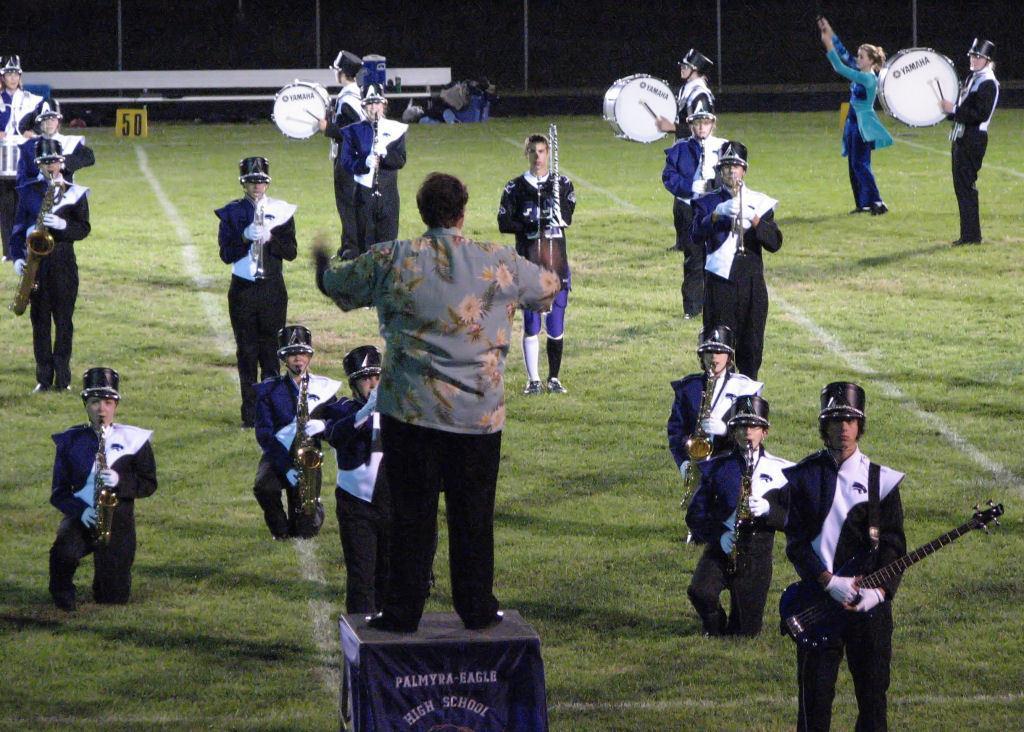How would you summarize this image in a sentence or two? In this image, we can see people wearing uniforms, caps and holding musical instruments. In the background, there is a bench and we can see a board, bags and a fence and there is a man standing on the stand and holding an object. At the bottom, there is ground. 